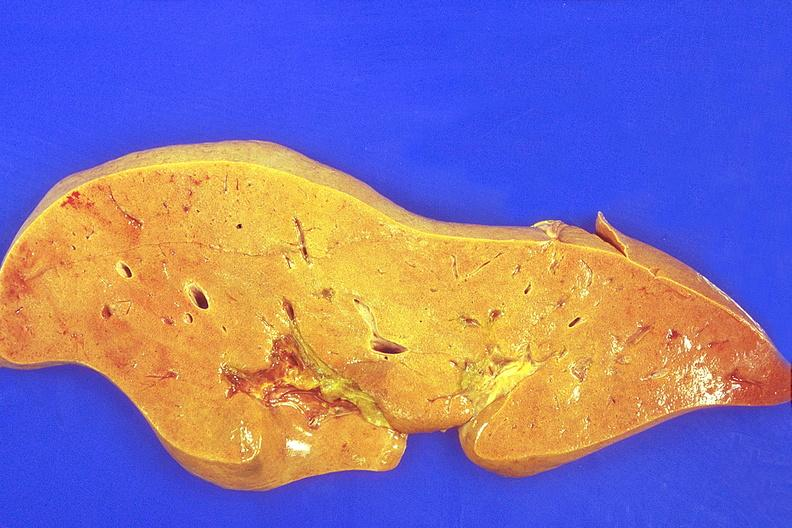what is present?
Answer the question using a single word or phrase. Hepatobiliary 